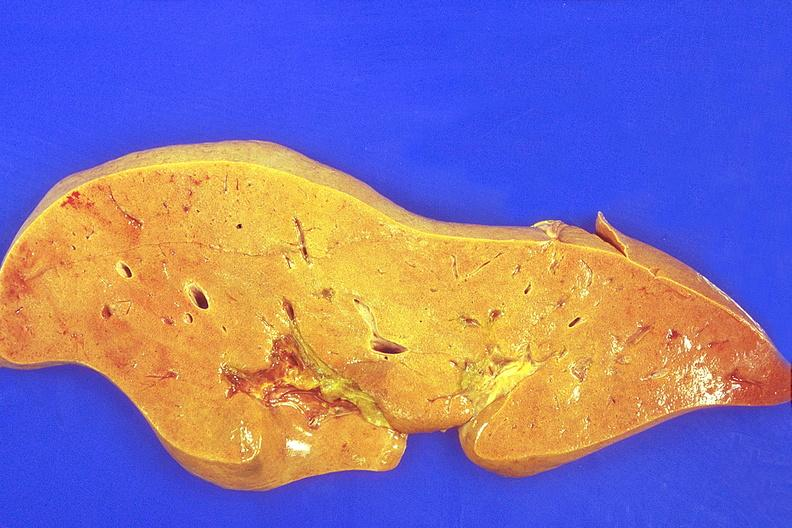what is present?
Answer the question using a single word or phrase. Hepatobiliary 